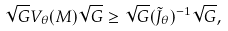Convert formula to latex. <formula><loc_0><loc_0><loc_500><loc_500>\sqrt { G } V _ { \theta } ( M ) \sqrt { G } \geq \sqrt { G } ( \tilde { J } _ { \theta } ) ^ { - 1 } \sqrt { G } ,</formula> 